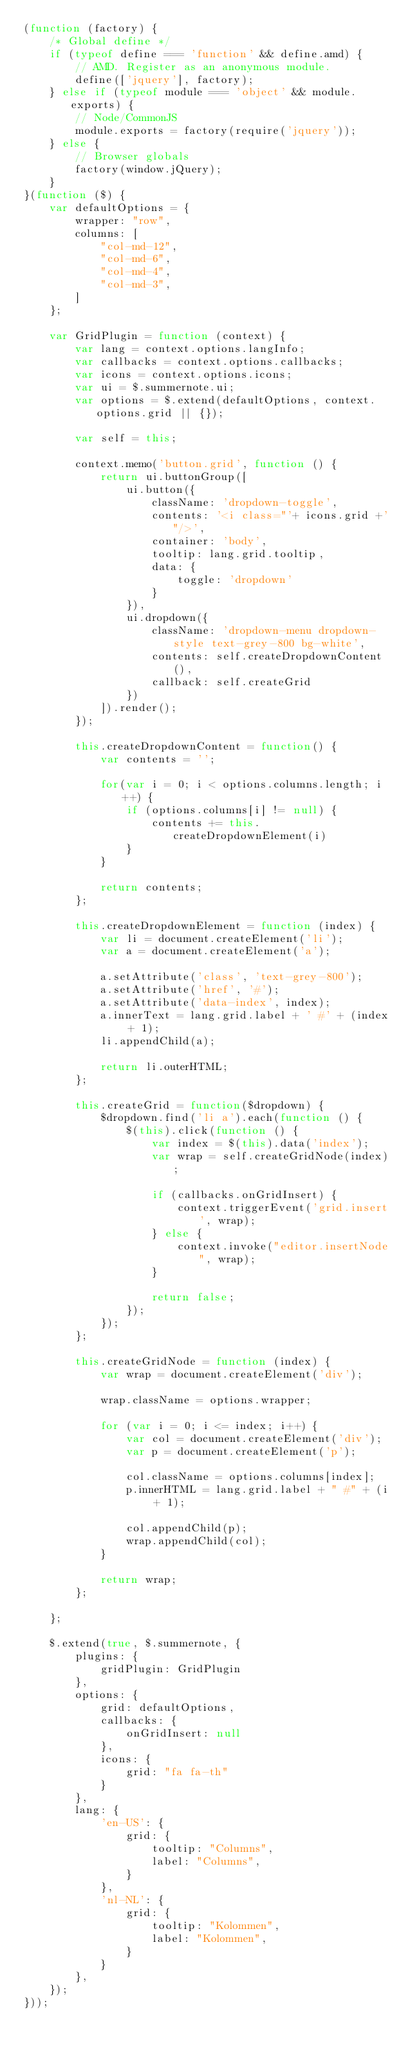<code> <loc_0><loc_0><loc_500><loc_500><_JavaScript_>(function (factory) {
    /* Global define */
    if (typeof define === 'function' && define.amd) {
        // AMD. Register as an anonymous module.
        define(['jquery'], factory);
    } else if (typeof module === 'object' && module.exports) {
        // Node/CommonJS
        module.exports = factory(require('jquery'));
    } else {
        // Browser globals
        factory(window.jQuery);
    }
}(function ($) {
    var defaultOptions = {
        wrapper: "row",
        columns: [
            "col-md-12",
            "col-md-6",
            "col-md-4",
            "col-md-3",
        ]
    };

    var GridPlugin = function (context) {
        var lang = context.options.langInfo;
        var callbacks = context.options.callbacks;
        var icons = context.options.icons;
        var ui = $.summernote.ui;
        var options = $.extend(defaultOptions, context.options.grid || {});

        var self = this;

        context.memo('button.grid', function () {
            return ui.buttonGroup([
                ui.button({
                    className: 'dropdown-toggle',
                    contents: '<i class="'+ icons.grid +'"/>',
                    container: 'body',
                    tooltip: lang.grid.tooltip,
                    data: {
                        toggle: 'dropdown'
                    }
                }),
                ui.dropdown({
                    className: 'dropdown-menu dropdown-style text-grey-800 bg-white',
                    contents: self.createDropdownContent(),
                    callback: self.createGrid
                })
            ]).render();
        });

        this.createDropdownContent = function() {
            var contents = '';

            for(var i = 0; i < options.columns.length; i++) {
                if (options.columns[i] != null) {
                    contents += this.createDropdownElement(i)
                }
            }

            return contents;
        };

        this.createDropdownElement = function (index) {
            var li = document.createElement('li');
            var a = document.createElement('a');

            a.setAttribute('class', 'text-grey-800');
            a.setAttribute('href', '#');
            a.setAttribute('data-index', index);
            a.innerText = lang.grid.label + ' #' + (index + 1);
            li.appendChild(a);

            return li.outerHTML;
        };

        this.createGrid = function($dropdown) {
            $dropdown.find('li a').each(function () {
                $(this).click(function () {
                    var index = $(this).data('index');
                    var wrap = self.createGridNode(index);

                    if (callbacks.onGridInsert) {
                        context.triggerEvent('grid.insert', wrap);
                    } else {
                        context.invoke("editor.insertNode", wrap);
                    }

                    return false;
                });
            });
        };

        this.createGridNode = function (index) {
            var wrap = document.createElement('div');

            wrap.className = options.wrapper;

            for (var i = 0; i <= index; i++) {
                var col = document.createElement('div');
                var p = document.createElement('p');

                col.className = options.columns[index];
                p.innerHTML = lang.grid.label + " #" + (i + 1);

                col.appendChild(p);
                wrap.appendChild(col);
            }

            return wrap;
        };

    };

    $.extend(true, $.summernote, {
        plugins: {
            gridPlugin: GridPlugin
        },
        options: {
            grid: defaultOptions,
            callbacks: {
                onGridInsert: null
            },
            icons: {
                grid: "fa fa-th"
            }
        },
        lang: {
            'en-US': {
                grid: {
                    tooltip: "Columns",
                    label: "Columns",
                }
            },
            'nl-NL': {
                grid: {
                    tooltip: "Kolommen",
                    label: "Kolommen",
                }
            }
        },
    });
}));
</code> 